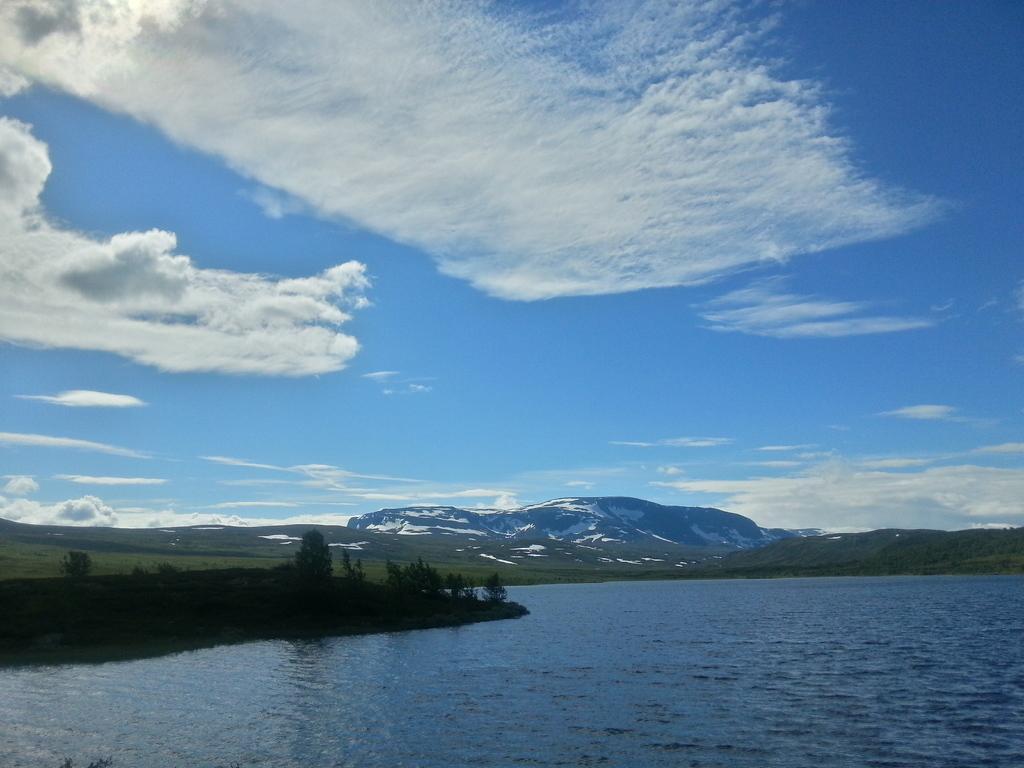How would you summarize this image in a sentence or two? In this picture we can see trees, water, grass, mountains and in the background we can see the sky with clouds. 